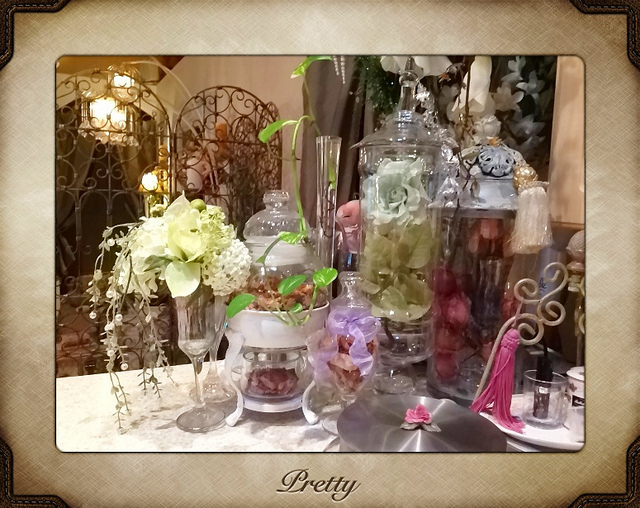Please extract the text content from this image. Lretty 